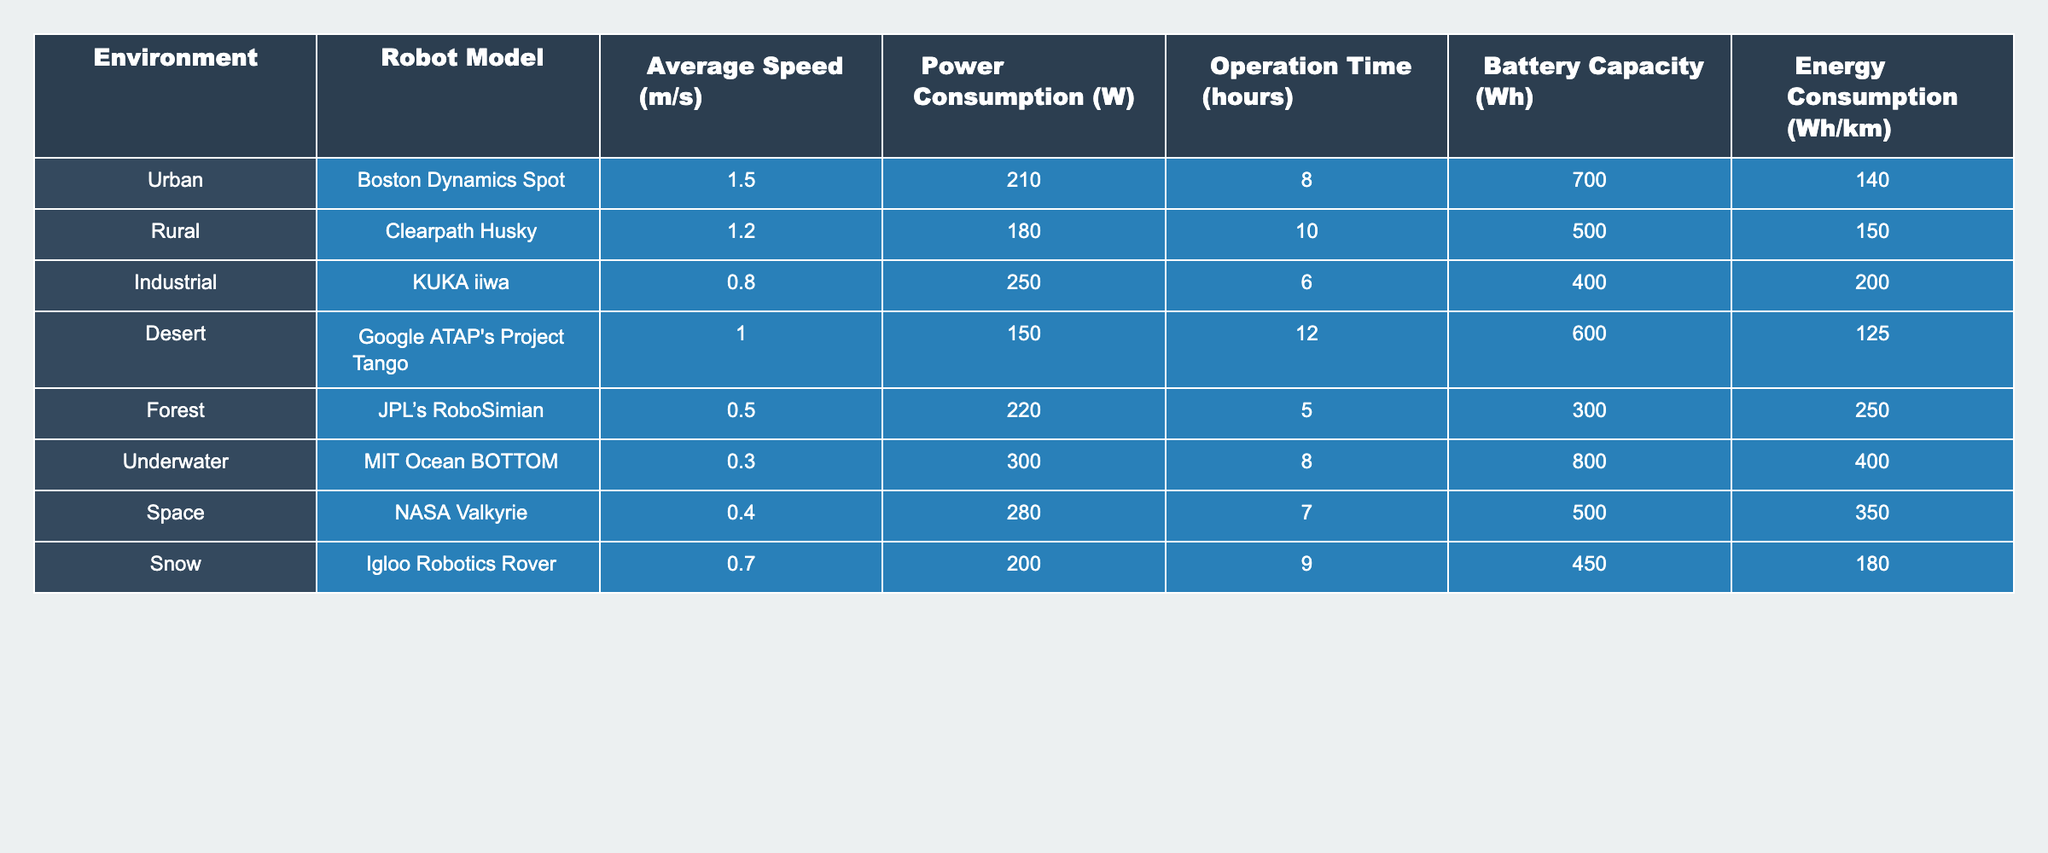What is the average power consumption of the robots in urban environments? There is one robot in the urban section: Boston Dynamics Spot with a power consumption of 210 W. Thus, the average is simply 210 W.
Answer: 210 W Which robot has the highest energy consumption per kilometer? From the table, JPL’s RoboSimian has the highest energy consumption at 250 Wh/km.
Answer: 250 Wh/km What is the total operation time of all the robots listed? To find the total operation time, we sum the operation times: 8 + 10 + 6 + 12 + 5 + 8 + 7 + 9 = 65 hours.
Answer: 65 hours Is the power consumption of the MIT Ocean BOTTOM greater than that of the KUKA iiwa? The power consumption of MIT Ocean BOTTOM is 300 W and KUKA iiwa is 250 W. Since 300 > 250, the statement is true.
Answer: Yes How much greater is the battery capacity of the Google ATAP's Project Tango compared to the Clearpath Husky? The battery capacity of Google ATAP's Project Tango is 600 Wh, while that of Clearpath Husky is 500 Wh. The difference is 600 - 500 = 100 Wh.
Answer: 100 Wh What is the speed range (maximum - minimum) of all the robot models listed? The maximum speed is of Boston Dynamics Spot at 1.5 m/s and the minimum is of JPL’s RoboSimian at 0.5 m/s. Therefore, the speed range is 1.5 - 0.5 = 1.0 m/s.
Answer: 1.0 m/s Which environment has the highest average battery capacity among the robots? Urban, Rural, Industrial, Desert, Forest, Underwater, Space, and Snow have the respective battery capacities of 700, 500, 400, 600, 300, 800, 500, and 450 Wh. The highest is MIT Ocean BOTTOM in Underwater with 800 Wh.
Answer: Underwater Calculate the average energy consumption of robots working in snowy and desert environments. The energy consumption for Igloo Robotics Rover in Snow is 180 Wh/km, and for Google ATAP's Project Tango in desert it is 125 Wh/km. The average is (180 + 125) / 2 = 152.5 Wh/km.
Answer: 152.5 Wh/km Which robot operates the longest before needing a recharge? Looking at the operation time, Clearpath Husky operates for 10 hours, which is the longest compared to others.
Answer: Clearpath Husky Is the average speed of robots in industrial environments higher than those in rural environments? The average speed for KUKA iiwa in industrial is 0.8 m/s and for Clearpath Husky in rural is 1.2 m/s. Since 0.8 < 1.2, the average speed is not higher.
Answer: No 